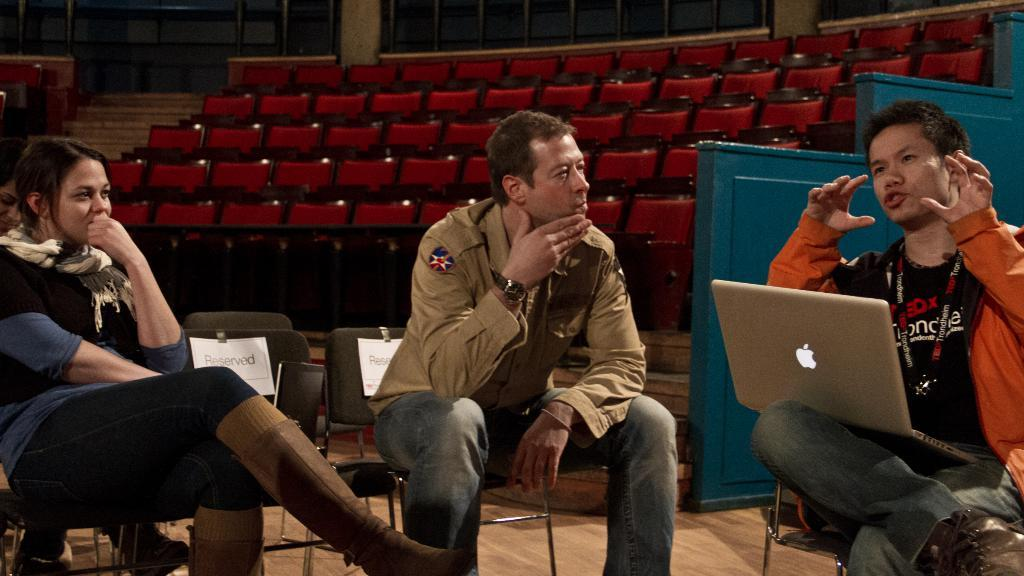What are the people in the image doing? The people in the image are sitting on chairs. What electronic device can be seen on the right side of the image? There is a silver color laptop on the right side of the image. What color are the chairs in the background of the image? The chairs in the background of the image are red color. What architectural feature is visible in the image? There are stairs visible in the image. How many bikes are parked next to the stairs in the image? There are no bikes present in the image; only chairs, a laptop, and stairs are visible. 